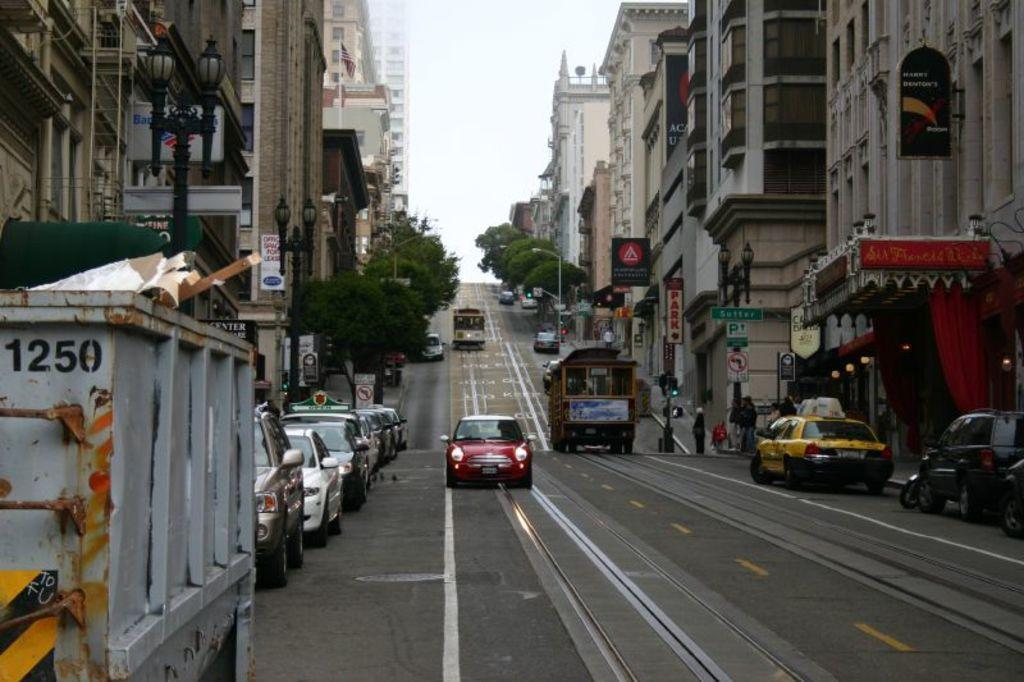<image>
Present a compact description of the photo's key features. Red vehicle going down a street with a parked container that says 1250 on it. 